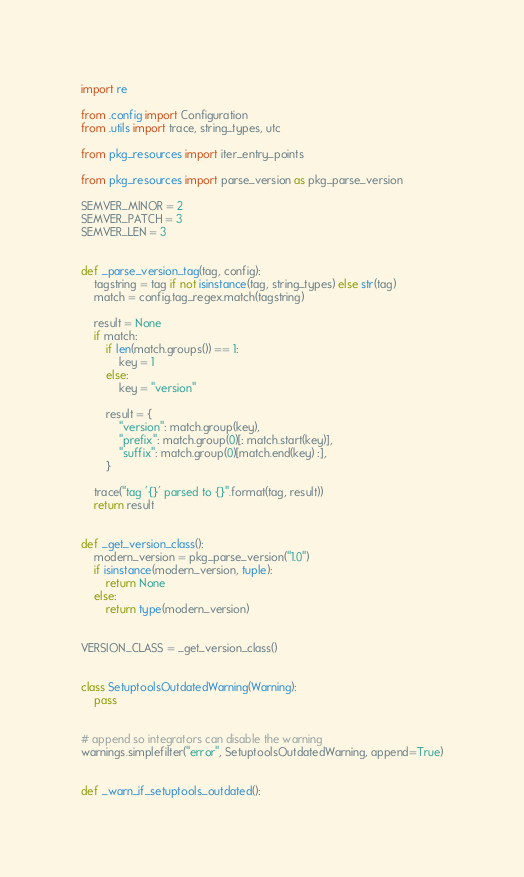<code> <loc_0><loc_0><loc_500><loc_500><_Python_>import re

from .config import Configuration
from .utils import trace, string_types, utc

from pkg_resources import iter_entry_points

from pkg_resources import parse_version as pkg_parse_version

SEMVER_MINOR = 2
SEMVER_PATCH = 3
SEMVER_LEN = 3


def _parse_version_tag(tag, config):
    tagstring = tag if not isinstance(tag, string_types) else str(tag)
    match = config.tag_regex.match(tagstring)

    result = None
    if match:
        if len(match.groups()) == 1:
            key = 1
        else:
            key = "version"

        result = {
            "version": match.group(key),
            "prefix": match.group(0)[: match.start(key)],
            "suffix": match.group(0)[match.end(key) :],
        }

    trace("tag '{}' parsed to {}".format(tag, result))
    return result


def _get_version_class():
    modern_version = pkg_parse_version("1.0")
    if isinstance(modern_version, tuple):
        return None
    else:
        return type(modern_version)


VERSION_CLASS = _get_version_class()


class SetuptoolsOutdatedWarning(Warning):
    pass


# append so integrators can disable the warning
warnings.simplefilter("error", SetuptoolsOutdatedWarning, append=True)


def _warn_if_setuptools_outdated():</code> 